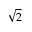<formula> <loc_0><loc_0><loc_500><loc_500>\sqrt { 2 }</formula> 